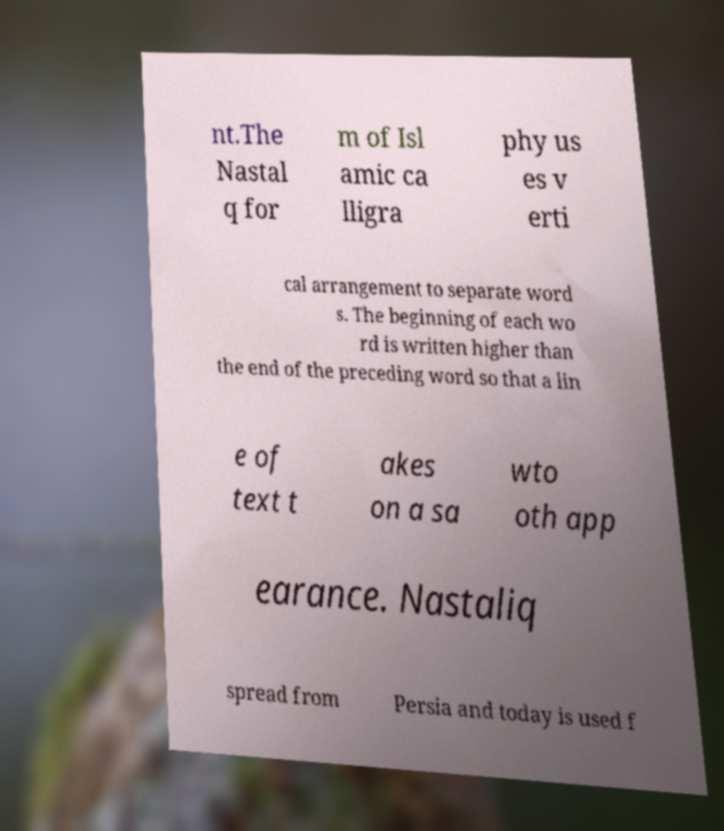For documentation purposes, I need the text within this image transcribed. Could you provide that? nt.The Nastal q for m of Isl amic ca lligra phy us es v erti cal arrangement to separate word s. The beginning of each wo rd is written higher than the end of the preceding word so that a lin e of text t akes on a sa wto oth app earance. Nastaliq spread from Persia and today is used f 